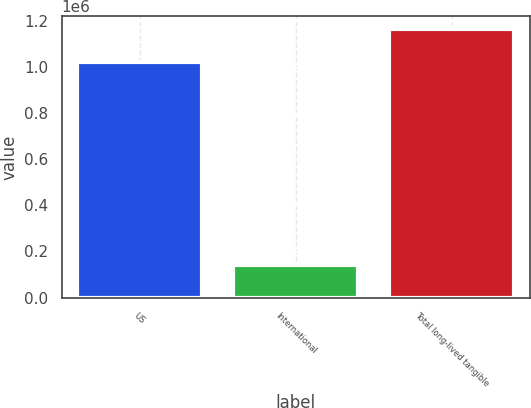Convert chart to OTSL. <chart><loc_0><loc_0><loc_500><loc_500><bar_chart><fcel>US<fcel>International<fcel>Total long-lived tangible<nl><fcel>1.01864e+06<fcel>142537<fcel>1.16118e+06<nl></chart> 